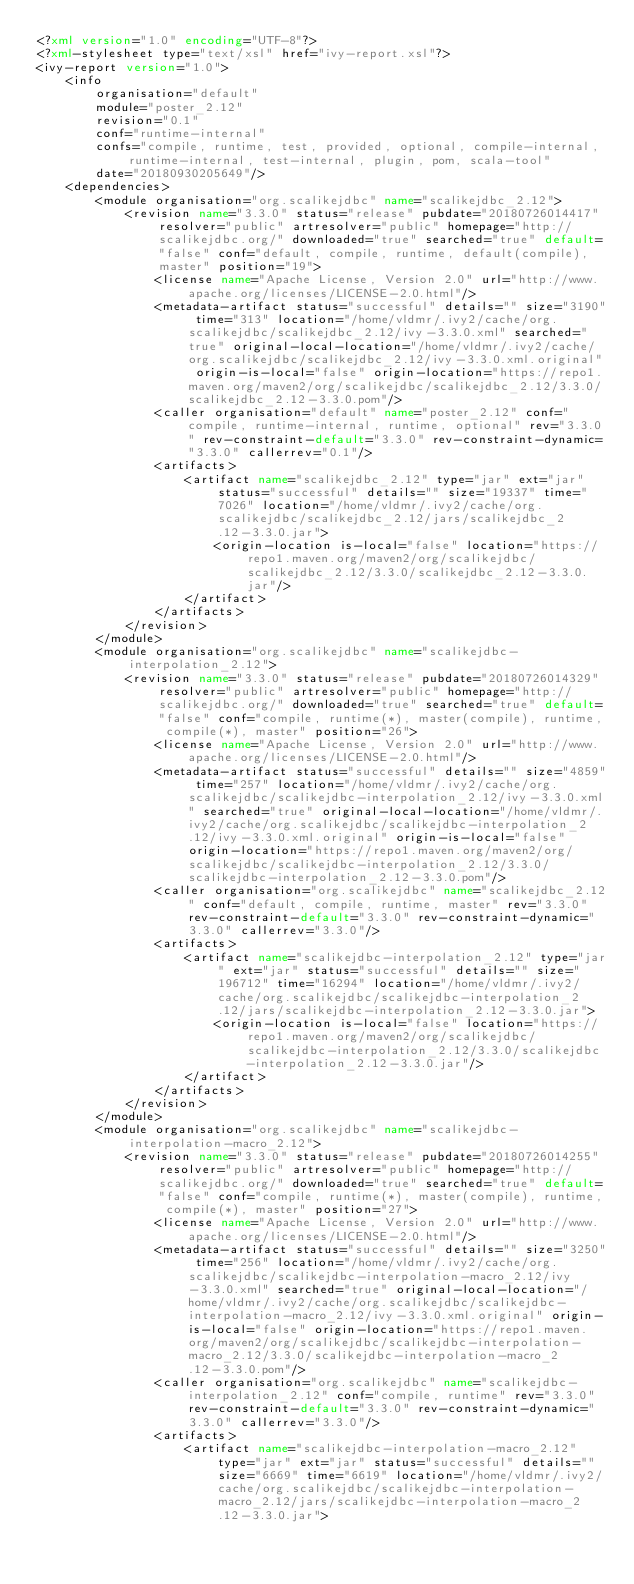<code> <loc_0><loc_0><loc_500><loc_500><_XML_><?xml version="1.0" encoding="UTF-8"?>
<?xml-stylesheet type="text/xsl" href="ivy-report.xsl"?>
<ivy-report version="1.0">
	<info
		organisation="default"
		module="poster_2.12"
		revision="0.1"
		conf="runtime-internal"
		confs="compile, runtime, test, provided, optional, compile-internal, runtime-internal, test-internal, plugin, pom, scala-tool"
		date="20180930205649"/>
	<dependencies>
		<module organisation="org.scalikejdbc" name="scalikejdbc_2.12">
			<revision name="3.3.0" status="release" pubdate="20180726014417" resolver="public" artresolver="public" homepage="http://scalikejdbc.org/" downloaded="true" searched="true" default="false" conf="default, compile, runtime, default(compile), master" position="19">
				<license name="Apache License, Version 2.0" url="http://www.apache.org/licenses/LICENSE-2.0.html"/>
				<metadata-artifact status="successful" details="" size="3190" time="313" location="/home/vldmr/.ivy2/cache/org.scalikejdbc/scalikejdbc_2.12/ivy-3.3.0.xml" searched="true" original-local-location="/home/vldmr/.ivy2/cache/org.scalikejdbc/scalikejdbc_2.12/ivy-3.3.0.xml.original" origin-is-local="false" origin-location="https://repo1.maven.org/maven2/org/scalikejdbc/scalikejdbc_2.12/3.3.0/scalikejdbc_2.12-3.3.0.pom"/>
				<caller organisation="default" name="poster_2.12" conf="compile, runtime-internal, runtime, optional" rev="3.3.0" rev-constraint-default="3.3.0" rev-constraint-dynamic="3.3.0" callerrev="0.1"/>
				<artifacts>
					<artifact name="scalikejdbc_2.12" type="jar" ext="jar" status="successful" details="" size="19337" time="7026" location="/home/vldmr/.ivy2/cache/org.scalikejdbc/scalikejdbc_2.12/jars/scalikejdbc_2.12-3.3.0.jar">
						<origin-location is-local="false" location="https://repo1.maven.org/maven2/org/scalikejdbc/scalikejdbc_2.12/3.3.0/scalikejdbc_2.12-3.3.0.jar"/>
					</artifact>
				</artifacts>
			</revision>
		</module>
		<module organisation="org.scalikejdbc" name="scalikejdbc-interpolation_2.12">
			<revision name="3.3.0" status="release" pubdate="20180726014329" resolver="public" artresolver="public" homepage="http://scalikejdbc.org/" downloaded="true" searched="true" default="false" conf="compile, runtime(*), master(compile), runtime, compile(*), master" position="26">
				<license name="Apache License, Version 2.0" url="http://www.apache.org/licenses/LICENSE-2.0.html"/>
				<metadata-artifact status="successful" details="" size="4859" time="257" location="/home/vldmr/.ivy2/cache/org.scalikejdbc/scalikejdbc-interpolation_2.12/ivy-3.3.0.xml" searched="true" original-local-location="/home/vldmr/.ivy2/cache/org.scalikejdbc/scalikejdbc-interpolation_2.12/ivy-3.3.0.xml.original" origin-is-local="false" origin-location="https://repo1.maven.org/maven2/org/scalikejdbc/scalikejdbc-interpolation_2.12/3.3.0/scalikejdbc-interpolation_2.12-3.3.0.pom"/>
				<caller organisation="org.scalikejdbc" name="scalikejdbc_2.12" conf="default, compile, runtime, master" rev="3.3.0" rev-constraint-default="3.3.0" rev-constraint-dynamic="3.3.0" callerrev="3.3.0"/>
				<artifacts>
					<artifact name="scalikejdbc-interpolation_2.12" type="jar" ext="jar" status="successful" details="" size="196712" time="16294" location="/home/vldmr/.ivy2/cache/org.scalikejdbc/scalikejdbc-interpolation_2.12/jars/scalikejdbc-interpolation_2.12-3.3.0.jar">
						<origin-location is-local="false" location="https://repo1.maven.org/maven2/org/scalikejdbc/scalikejdbc-interpolation_2.12/3.3.0/scalikejdbc-interpolation_2.12-3.3.0.jar"/>
					</artifact>
				</artifacts>
			</revision>
		</module>
		<module organisation="org.scalikejdbc" name="scalikejdbc-interpolation-macro_2.12">
			<revision name="3.3.0" status="release" pubdate="20180726014255" resolver="public" artresolver="public" homepage="http://scalikejdbc.org/" downloaded="true" searched="true" default="false" conf="compile, runtime(*), master(compile), runtime, compile(*), master" position="27">
				<license name="Apache License, Version 2.0" url="http://www.apache.org/licenses/LICENSE-2.0.html"/>
				<metadata-artifact status="successful" details="" size="3250" time="256" location="/home/vldmr/.ivy2/cache/org.scalikejdbc/scalikejdbc-interpolation-macro_2.12/ivy-3.3.0.xml" searched="true" original-local-location="/home/vldmr/.ivy2/cache/org.scalikejdbc/scalikejdbc-interpolation-macro_2.12/ivy-3.3.0.xml.original" origin-is-local="false" origin-location="https://repo1.maven.org/maven2/org/scalikejdbc/scalikejdbc-interpolation-macro_2.12/3.3.0/scalikejdbc-interpolation-macro_2.12-3.3.0.pom"/>
				<caller organisation="org.scalikejdbc" name="scalikejdbc-interpolation_2.12" conf="compile, runtime" rev="3.3.0" rev-constraint-default="3.3.0" rev-constraint-dynamic="3.3.0" callerrev="3.3.0"/>
				<artifacts>
					<artifact name="scalikejdbc-interpolation-macro_2.12" type="jar" ext="jar" status="successful" details="" size="6669" time="6619" location="/home/vldmr/.ivy2/cache/org.scalikejdbc/scalikejdbc-interpolation-macro_2.12/jars/scalikejdbc-interpolation-macro_2.12-3.3.0.jar"></code> 